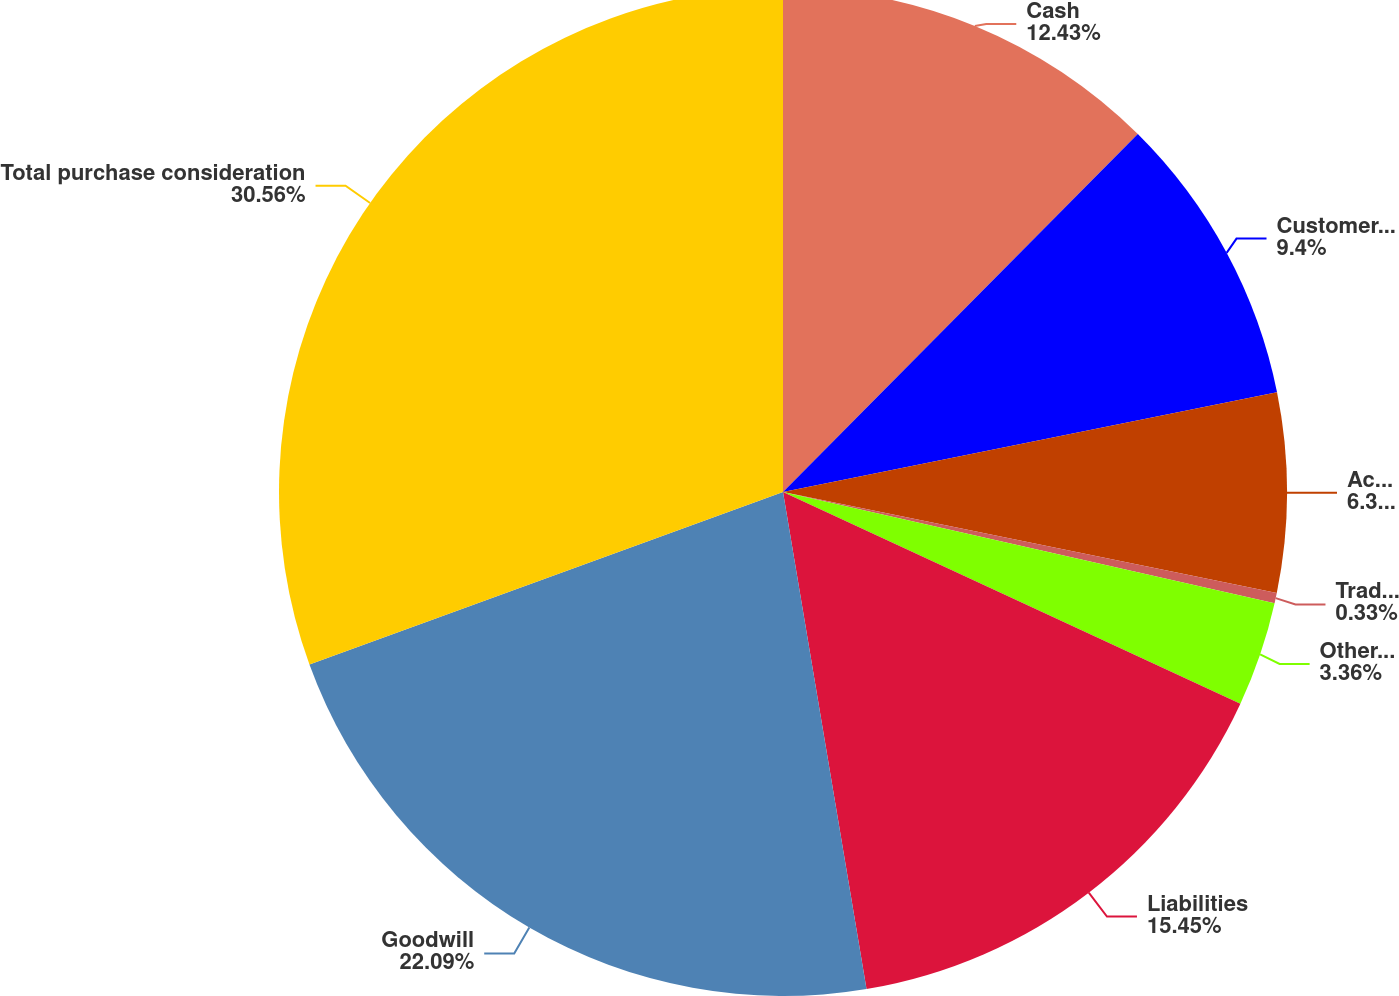<chart> <loc_0><loc_0><loc_500><loc_500><pie_chart><fcel>Cash<fcel>Customer-related intangible<fcel>Acquired technology<fcel>Trade name<fcel>Other assets<fcel>Liabilities<fcel>Goodwill<fcel>Total purchase consideration<nl><fcel>12.43%<fcel>9.4%<fcel>6.38%<fcel>0.33%<fcel>3.36%<fcel>15.45%<fcel>22.09%<fcel>30.56%<nl></chart> 